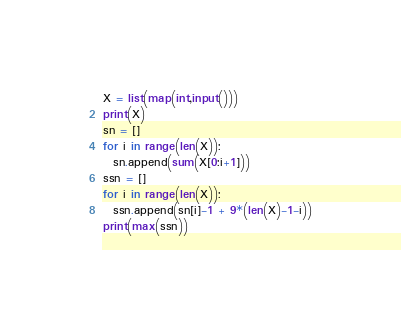<code> <loc_0><loc_0><loc_500><loc_500><_Python_>X = list(map(int,input()))
print(X)
sn = []
for i in range(len(X)):
  sn.append(sum(X[0:i+1]))
ssn = []
for i in range(len(X)):
  ssn.append(sn[i]-1 + 9*(len(X)-1-i))
print(max(ssn))</code> 